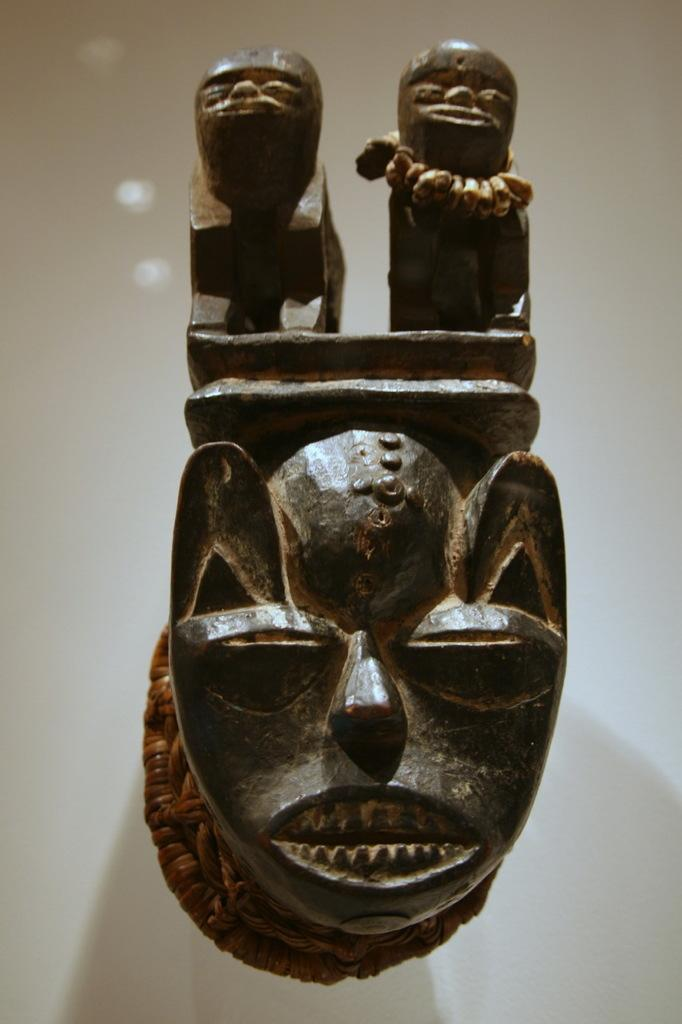What is the main subject of the image? There is a sculpture in the image. How is the sculpture positioned in relation to the wall? The sculpture is attached to a wall. What else can be seen in the background of the image? There is a wall visible in the background of the image. How does the beginner sculptor feel about their work in the wilderness? There is no information about a sculptor or their feelings in the image, nor is there any indication of a wilderness setting. 